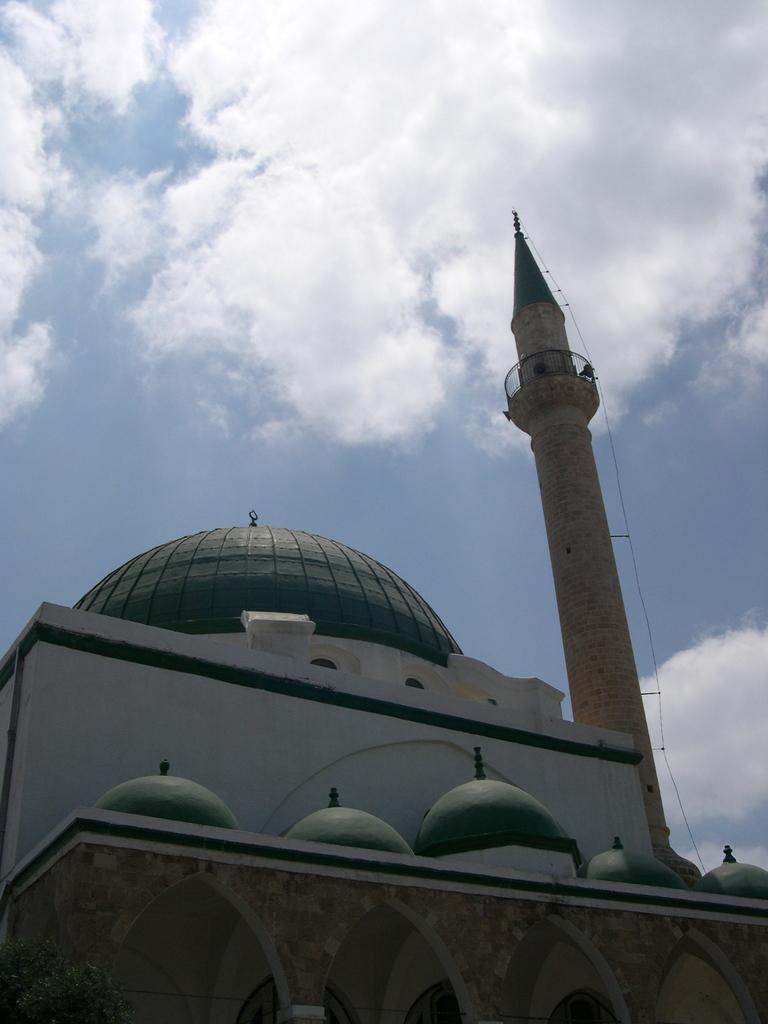Describe this image in one or two sentences. In this image we can see a building and a tower. In the background there is sky with clouds. 